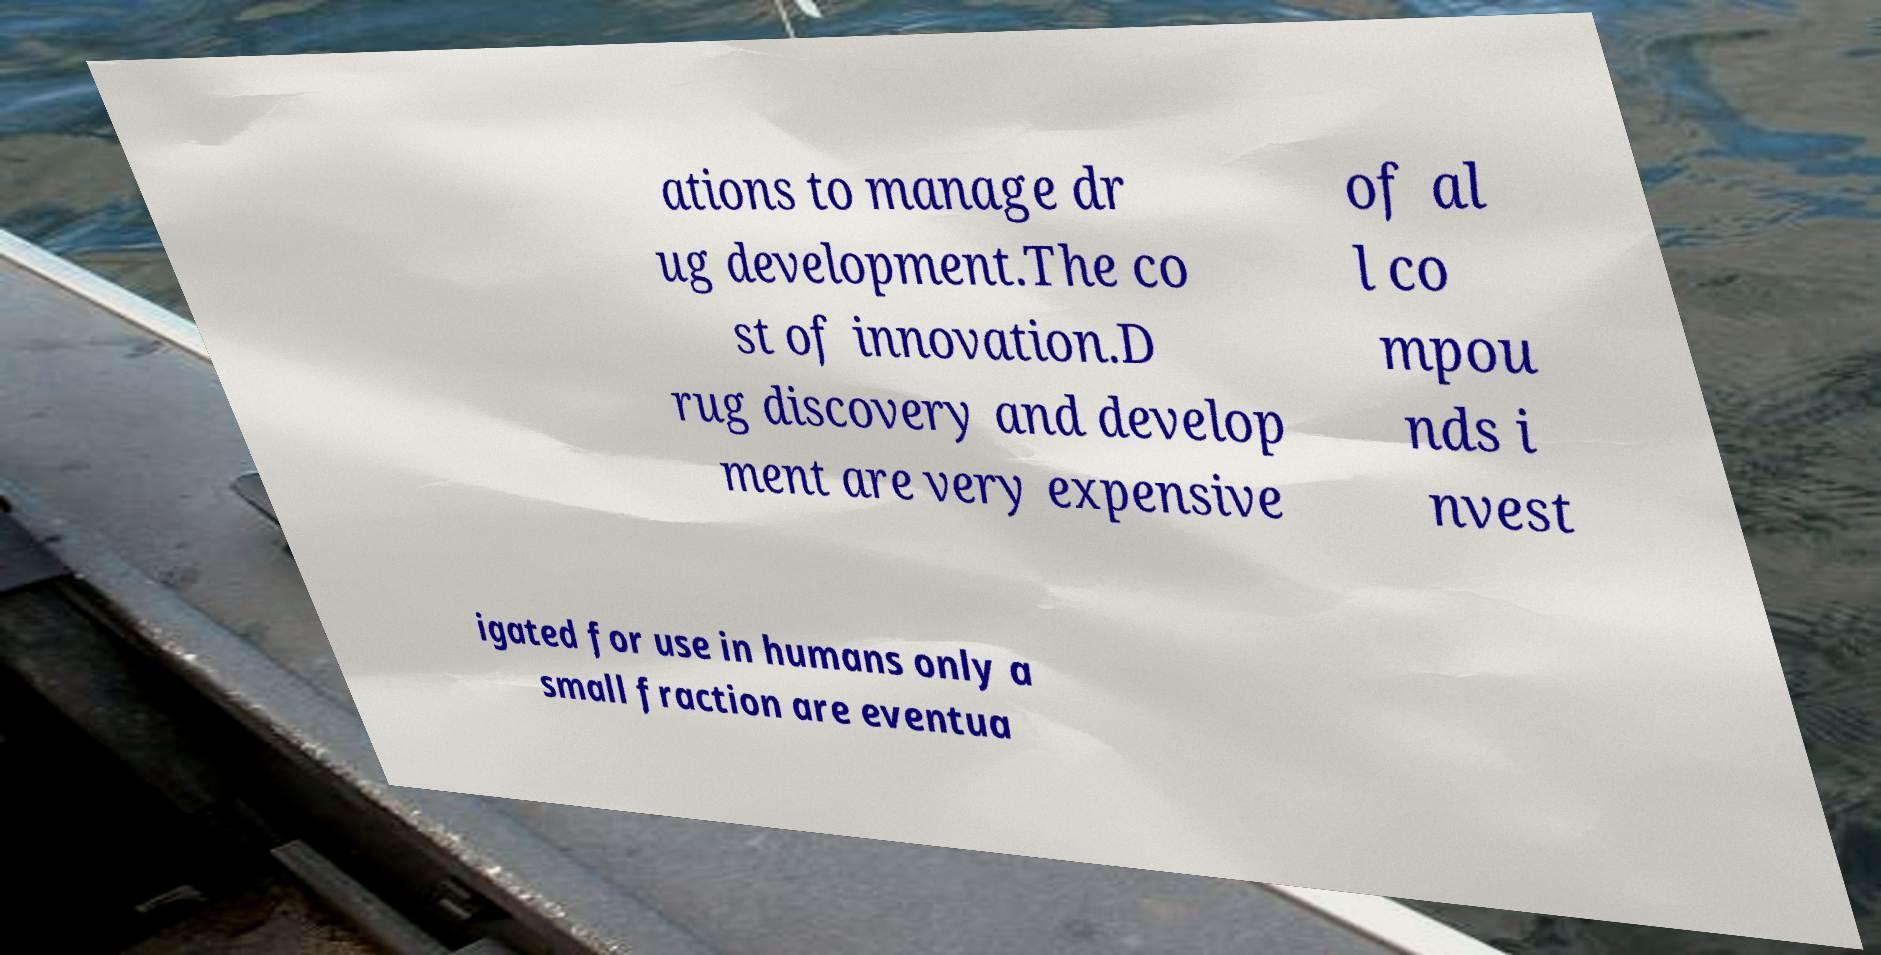Please read and relay the text visible in this image. What does it say? ations to manage dr ug development.The co st of innovation.D rug discovery and develop ment are very expensive of al l co mpou nds i nvest igated for use in humans only a small fraction are eventua 